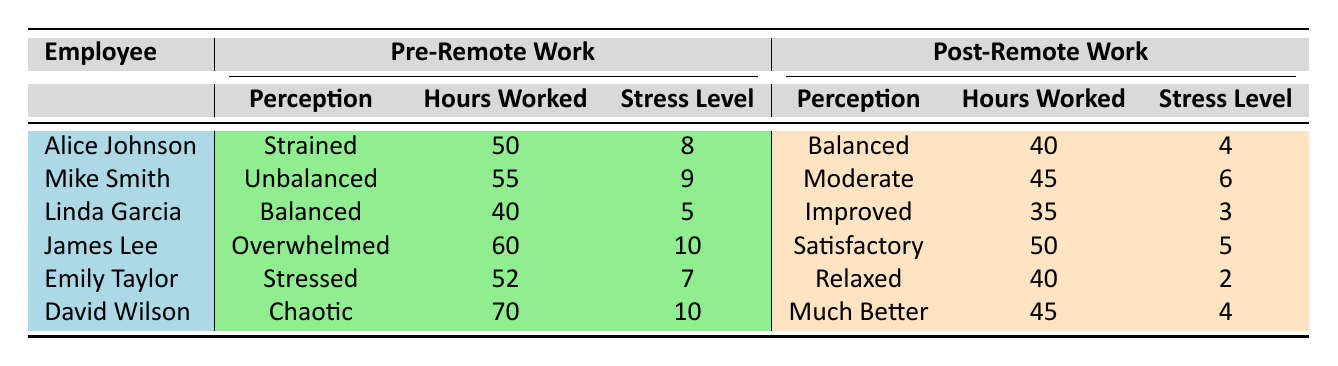What was Alice Johnson's pre-remote work stress level? Alice Johnson’s pre-remote work stress level is listed in the table under the "Pre-Remote Work" section. It shows a stress level of 8.
Answer: 8 How many hours did David Wilson work post-remote work? The table shows that David Wilson worked 45 hours after switching to remote work, which is indicated in the "Post-Remote Work" section for hours worked.
Answer: 45 Is Emily Taylor's perception of work-life balance better after remote work? Emily's pre-remote work perception was "Stressed," and after remote work, it changed to "Relaxed," indicating a significant improvement in her perception of work-life balance.
Answer: Yes What is the difference in hours worked between pre-remote and post-remote work for Mike Smith? Mike Smith worked 55 hours pre-remote and 45 hours post-remote. The difference is calculated as 55 - 45 = 10 hours.
Answer: 10 What is the average stress level of employees post-remote work? The post-remote work stress levels are 4, 6, 3, 5, 2, and 4. To calculate the average: (4 + 6 + 3 + 5 + 2 + 4) = 24, and divide by the number of employees (6), resulting in an average stress level of 4.
Answer: 4 Did any employee have the same perception before and after remote work? By reviewing the perceptions for each employee before and after remote work, it can be seen that Linda Garcia had a "Balanced" perception before remote work but improved to "Improved" afterward, so no one had the same perception.
Answer: No Which employee reduced their hours worked by the most? Comparing the hours worked before and after remote work for each employee, David Wilson reduced his hours from 70 to 45, which is a reduction of 25 hours, more than any other employee.
Answer: David Wilson What was the highest pre-remote work stress level recorded among employees? Looking at the pre-remote stress levels: 8, 9, 5, 10, 7, and 10, the highest recorded is 10, which belongs to James Lee and David Wilson.
Answer: 10 How many employees worked fewer hours after transitioning to remote work? Checking the hours worked before and after remote work for each employee reveals that Alice Johnson, Linda Garcia, Emily Taylor, and David Wilson all worked fewer hours post-remote work, totaling four employees.
Answer: 4 